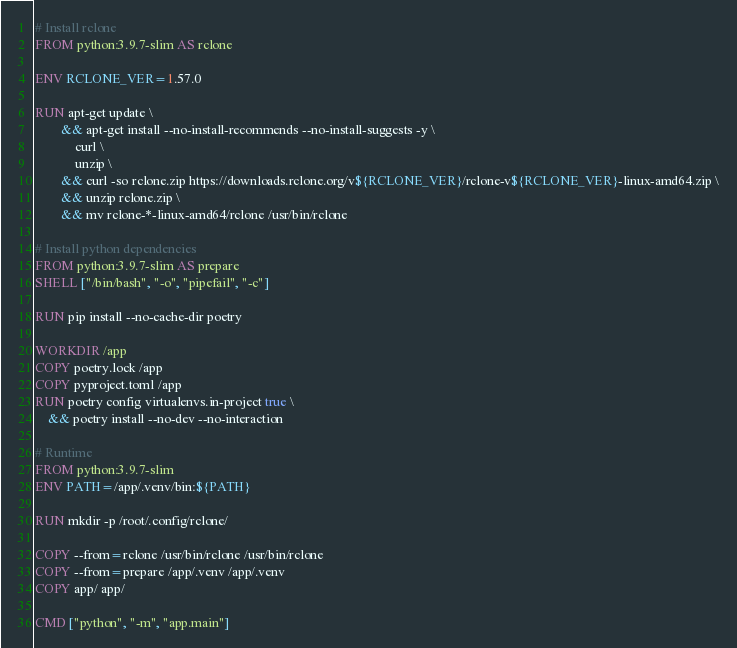<code> <loc_0><loc_0><loc_500><loc_500><_Dockerfile_># Install rclone
FROM python:3.9.7-slim AS rclone

ENV RCLONE_VER=1.57.0

RUN apt-get update \
		&& apt-get install --no-install-recommends --no-install-suggests -y \
			curl \
	        unzip \
	    && curl -so rclone.zip https://downloads.rclone.org/v${RCLONE_VER}/rclone-v${RCLONE_VER}-linux-amd64.zip \
	    && unzip rclone.zip \
	    && mv rclone-*-linux-amd64/rclone /usr/bin/rclone

# Install python dependencies
FROM python:3.9.7-slim AS prepare
SHELL ["/bin/bash", "-o", "pipefail", "-c"]

RUN pip install --no-cache-dir poetry

WORKDIR /app
COPY poetry.lock /app
COPY pyproject.toml /app
RUN poetry config virtualenvs.in-project true \
	&& poetry install --no-dev --no-interaction

# Runtime
FROM python:3.9.7-slim
ENV PATH=/app/.venv/bin:${PATH}

RUN mkdir -p /root/.config/rclone/

COPY --from=rclone /usr/bin/rclone /usr/bin/rclone
COPY --from=prepare /app/.venv /app/.venv
COPY app/ app/

CMD ["python", "-m", "app.main"]
</code> 